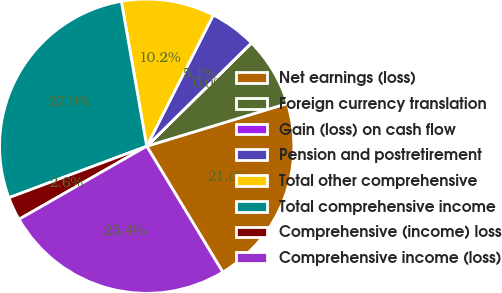Convert chart to OTSL. <chart><loc_0><loc_0><loc_500><loc_500><pie_chart><fcel>Net earnings (loss)<fcel>Foreign currency translation<fcel>Gain (loss) on cash flow<fcel>Pension and postretirement<fcel>Total other comprehensive<fcel>Total comprehensive income<fcel>Comprehensive (income) loss<fcel>Comprehensive income (loss)<nl><fcel>21.05%<fcel>7.68%<fcel>0.02%<fcel>5.13%<fcel>10.23%<fcel>27.94%<fcel>2.58%<fcel>25.38%<nl></chart> 